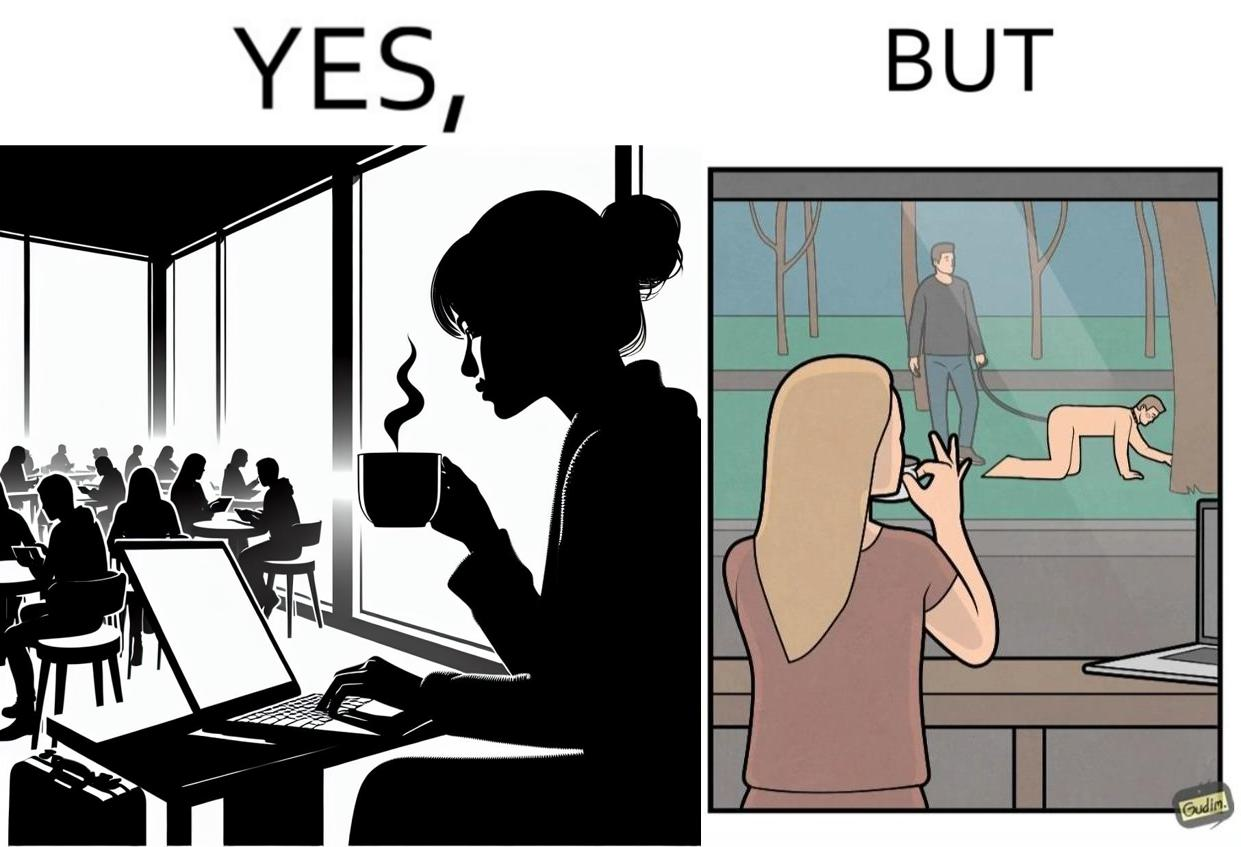What is shown in the left half versus the right half of this image? In the left part of the image: a woman inside a cafe enjoying a cup of some hot drink while doing her work on a laptop and watching outside through the window In the right part of the image: a person at some cafe, while looking at an act of slavery outside through the window 